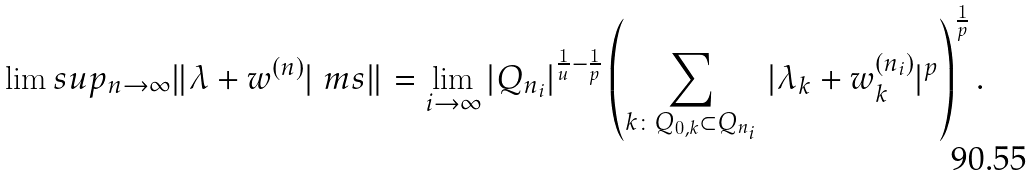<formula> <loc_0><loc_0><loc_500><loc_500>\lim s u p _ { n \to \infty } \| \lambda + w ^ { ( n ) } | \ m s \| = \lim _ { i \rightarrow \infty } | Q _ { n _ { i } } | ^ { \frac { 1 } { u } - \frac { 1 } { p } } \left ( \sum _ { k \colon Q _ { 0 , k } \subset Q _ { n _ { i } } } \, | \lambda _ { k } + w _ { k } ^ { ( n _ { i } ) } | ^ { p } \right ) ^ { \frac { 1 } { p } } .</formula> 